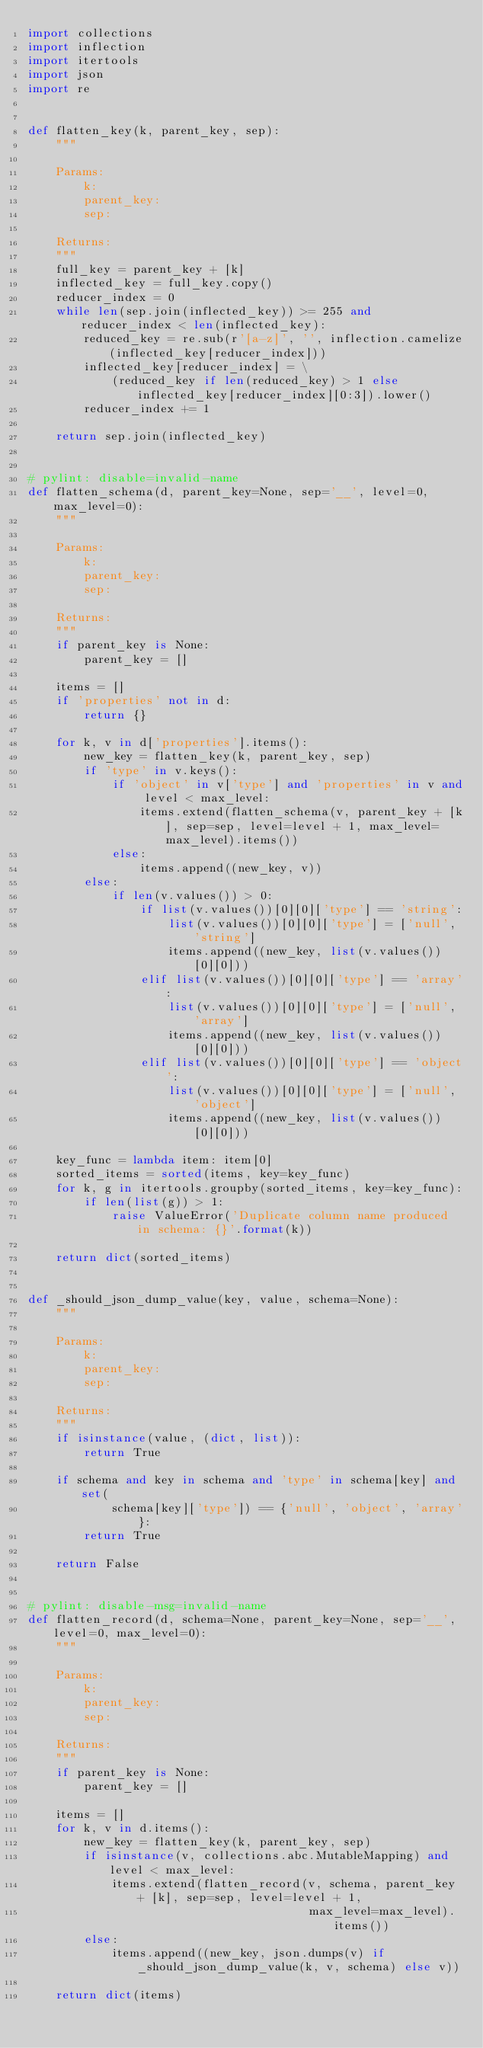Convert code to text. <code><loc_0><loc_0><loc_500><loc_500><_Python_>import collections
import inflection
import itertools
import json
import re


def flatten_key(k, parent_key, sep):
    """

    Params:
        k:
        parent_key:
        sep:

    Returns:
    """
    full_key = parent_key + [k]
    inflected_key = full_key.copy()
    reducer_index = 0
    while len(sep.join(inflected_key)) >= 255 and reducer_index < len(inflected_key):
        reduced_key = re.sub(r'[a-z]', '', inflection.camelize(inflected_key[reducer_index]))
        inflected_key[reducer_index] = \
            (reduced_key if len(reduced_key) > 1 else inflected_key[reducer_index][0:3]).lower()
        reducer_index += 1

    return sep.join(inflected_key)


# pylint: disable=invalid-name
def flatten_schema(d, parent_key=None, sep='__', level=0, max_level=0):
    """

    Params:
        k:
        parent_key:
        sep:

    Returns:
    """
    if parent_key is None:
        parent_key = []

    items = []
    if 'properties' not in d:
        return {}

    for k, v in d['properties'].items():
        new_key = flatten_key(k, parent_key, sep)
        if 'type' in v.keys():
            if 'object' in v['type'] and 'properties' in v and level < max_level:
                items.extend(flatten_schema(v, parent_key + [k], sep=sep, level=level + 1, max_level=max_level).items())
            else:
                items.append((new_key, v))
        else:
            if len(v.values()) > 0:
                if list(v.values())[0][0]['type'] == 'string':
                    list(v.values())[0][0]['type'] = ['null', 'string']
                    items.append((new_key, list(v.values())[0][0]))
                elif list(v.values())[0][0]['type'] == 'array':
                    list(v.values())[0][0]['type'] = ['null', 'array']
                    items.append((new_key, list(v.values())[0][0]))
                elif list(v.values())[0][0]['type'] == 'object':
                    list(v.values())[0][0]['type'] = ['null', 'object']
                    items.append((new_key, list(v.values())[0][0]))

    key_func = lambda item: item[0]
    sorted_items = sorted(items, key=key_func)
    for k, g in itertools.groupby(sorted_items, key=key_func):
        if len(list(g)) > 1:
            raise ValueError('Duplicate column name produced in schema: {}'.format(k))

    return dict(sorted_items)


def _should_json_dump_value(key, value, schema=None):
    """

    Params:
        k:
        parent_key:
        sep:

    Returns:
    """
    if isinstance(value, (dict, list)):
        return True

    if schema and key in schema and 'type' in schema[key] and set(
            schema[key]['type']) == {'null', 'object', 'array'}:
        return True

    return False


# pylint: disable-msg=invalid-name
def flatten_record(d, schema=None, parent_key=None, sep='__', level=0, max_level=0):
    """

    Params:
        k:
        parent_key:
        sep:

    Returns:
    """
    if parent_key is None:
        parent_key = []

    items = []
    for k, v in d.items():
        new_key = flatten_key(k, parent_key, sep)
        if isinstance(v, collections.abc.MutableMapping) and level < max_level:
            items.extend(flatten_record(v, schema, parent_key + [k], sep=sep, level=level + 1,
                                        max_level=max_level).items())
        else:
            items.append((new_key, json.dumps(v) if _should_json_dump_value(k, v, schema) else v))

    return dict(items)
</code> 